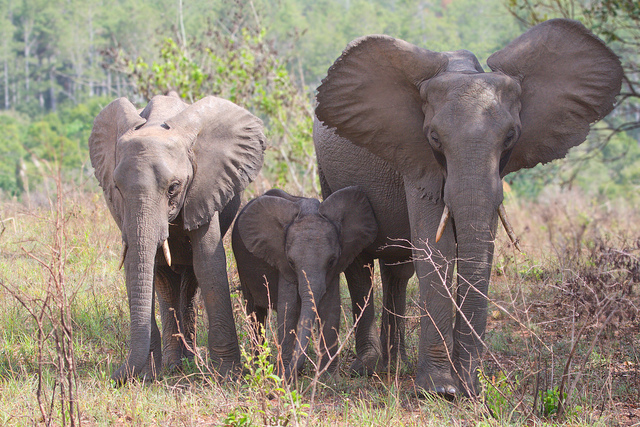Can you tell me about the habitat in which these elephants are found? The elephants are in a grassy savanna habitat with scattered trees and shrubs, typical of sub-Saharan Africa, which sustains a diverse ecosystem and provides the elephants with food, water, and cover.  Are these elephants at risk from any natural predators in this environment? While adult elephants have few natural predators due to their size, young elephants can be at risk from predators such as lions and crocodiles. Elephants are social animals and rely on the herd for protection. 